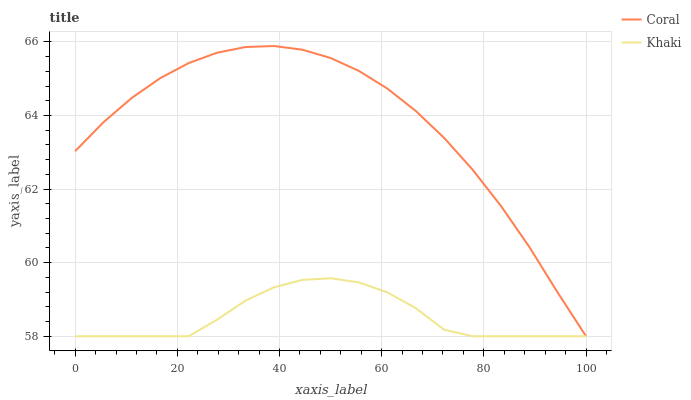Does Khaki have the minimum area under the curve?
Answer yes or no. Yes. Does Coral have the maximum area under the curve?
Answer yes or no. Yes. Does Khaki have the maximum area under the curve?
Answer yes or no. No. Is Coral the smoothest?
Answer yes or no. Yes. Is Khaki the roughest?
Answer yes or no. Yes. Is Khaki the smoothest?
Answer yes or no. No. Does Coral have the lowest value?
Answer yes or no. Yes. Does Coral have the highest value?
Answer yes or no. Yes. Does Khaki have the highest value?
Answer yes or no. No. Does Khaki intersect Coral?
Answer yes or no. Yes. Is Khaki less than Coral?
Answer yes or no. No. Is Khaki greater than Coral?
Answer yes or no. No. 